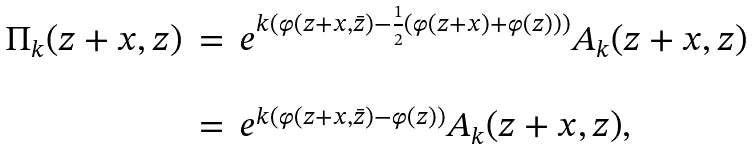Convert formula to latex. <formula><loc_0><loc_0><loc_500><loc_500>\begin{array} { l l l } \Pi _ { k } ( z + x , z ) & = & e ^ { k ( \varphi ( z + x , \bar { z } ) - \frac { 1 } { 2 } ( \varphi ( z + x ) + \varphi ( z ) ) ) } A _ { k } ( z + x , z ) \\ & & \\ & = & e ^ { k ( \varphi ( z + x , \bar { z } ) - \varphi ( z ) ) } A _ { k } ( z + x , z ) , \end{array}</formula> 